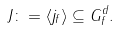<formula> <loc_0><loc_0><loc_500><loc_500>J \colon = \langle j _ { f } \rangle \subseteq G _ { f } ^ { d } .</formula> 